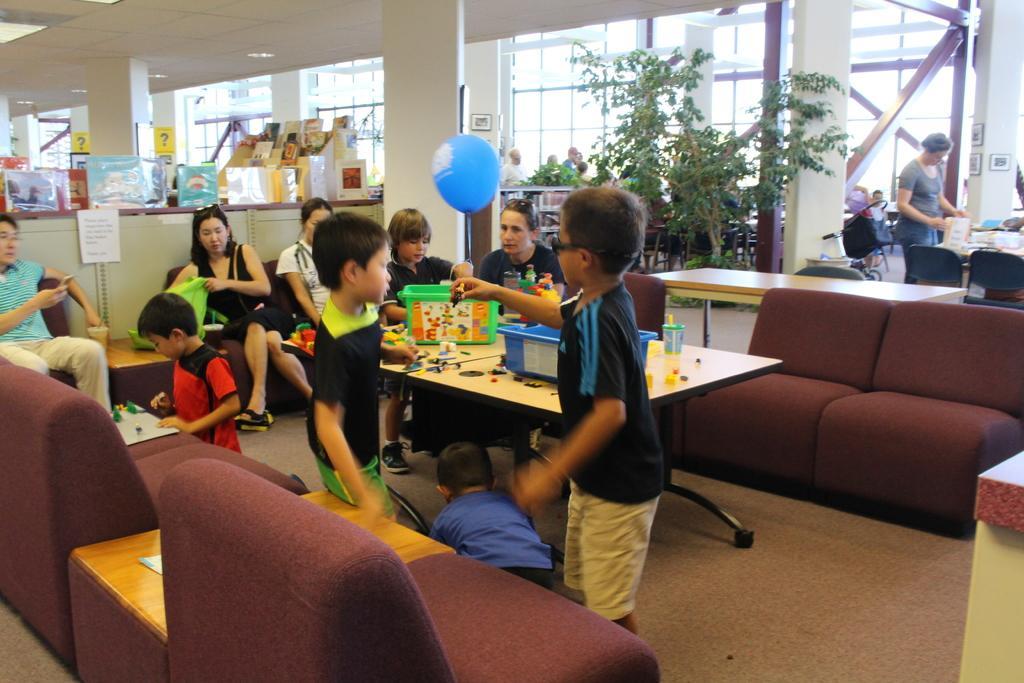How would you summarize this image in a sentence or two? In this picture we see so many people present. Here we have table. On the table, we see bottle, tub and some toys present. Here we see these people playing with the toys present here. Also we have a plant and we have chairs at the top right. It seems like a huge building. 